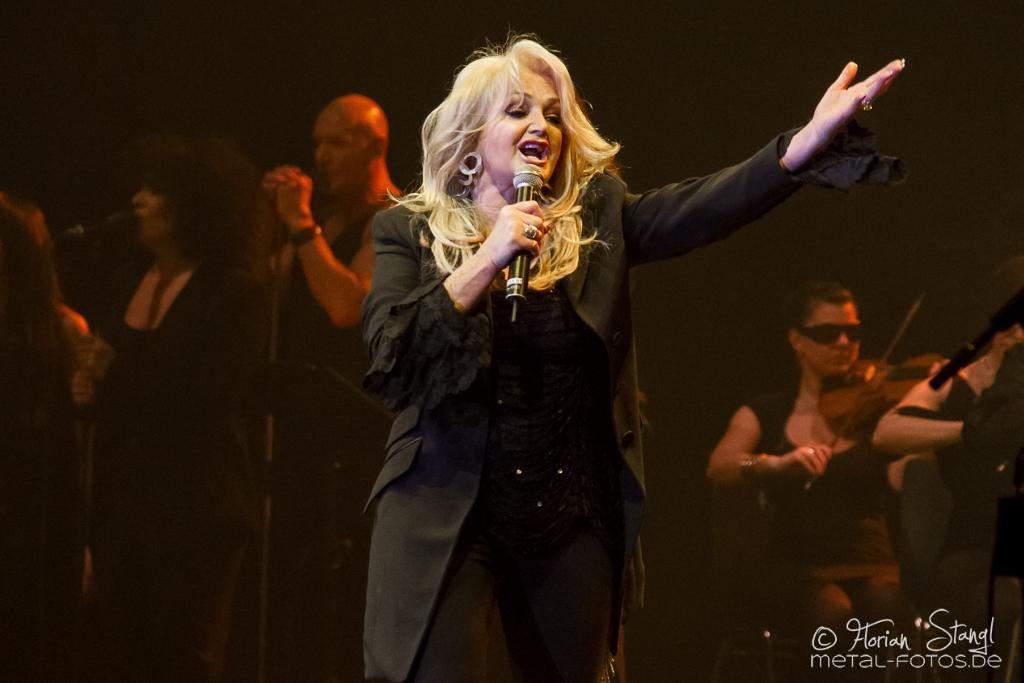How would you summarize this image in a sentence or two? In the foreground of this image, there is a woman in black dress holding a mic and standing. In the background, there are persons, few are playing musical instruments and some are holding mics and singing. 